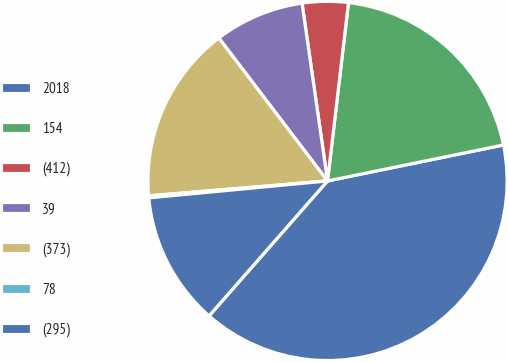Convert chart to OTSL. <chart><loc_0><loc_0><loc_500><loc_500><pie_chart><fcel>2018<fcel>154<fcel>(412)<fcel>39<fcel>(373)<fcel>78<fcel>(295)<nl><fcel>39.68%<fcel>19.93%<fcel>4.13%<fcel>8.08%<fcel>15.98%<fcel>0.18%<fcel>12.03%<nl></chart> 